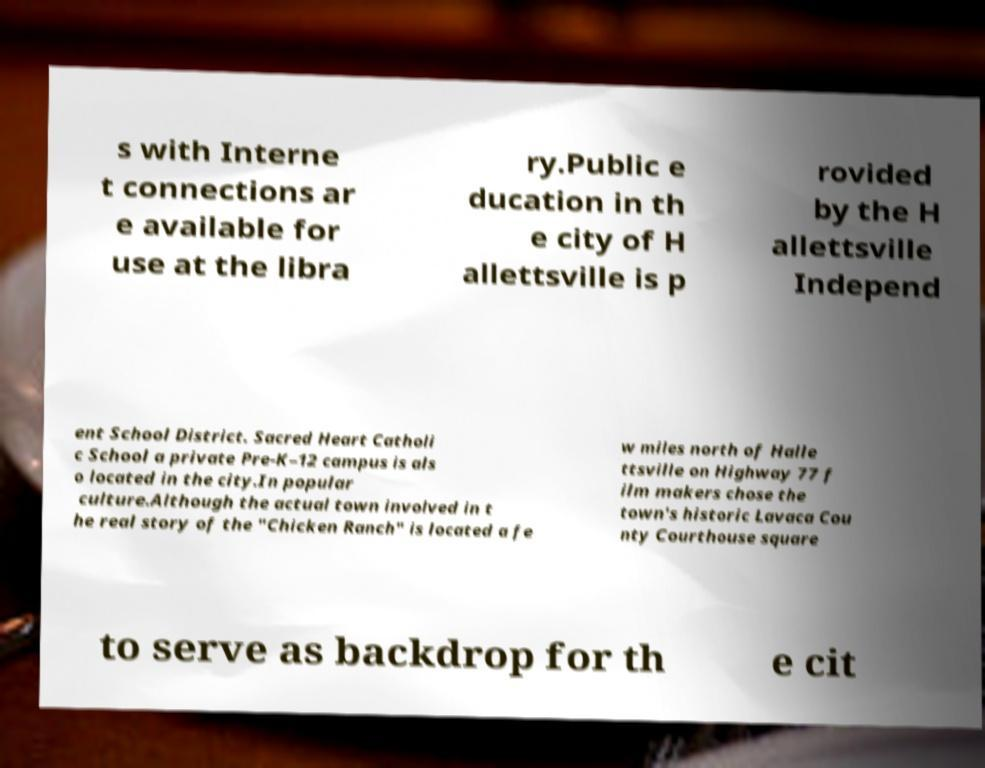What messages or text are displayed in this image? I need them in a readable, typed format. s with Interne t connections ar e available for use at the libra ry.Public e ducation in th e city of H allettsville is p rovided by the H allettsville Independ ent School District. Sacred Heart Catholi c School a private Pre-K–12 campus is als o located in the city.In popular culture.Although the actual town involved in t he real story of the "Chicken Ranch" is located a fe w miles north of Halle ttsville on Highway 77 f ilm makers chose the town's historic Lavaca Cou nty Courthouse square to serve as backdrop for th e cit 